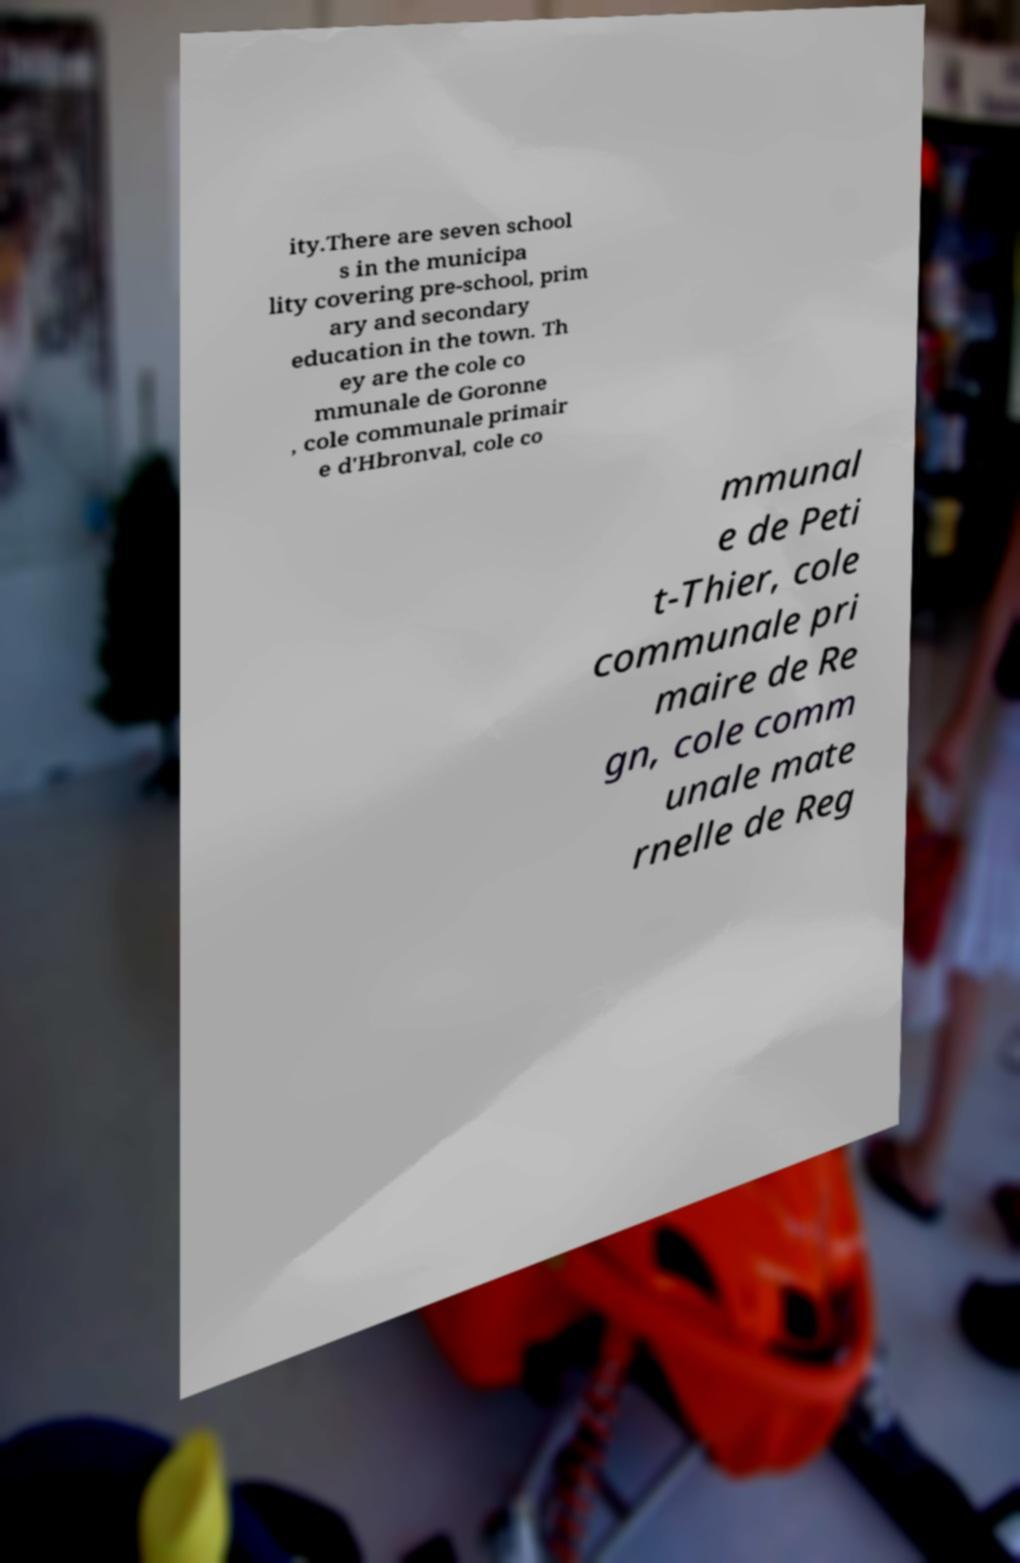Could you assist in decoding the text presented in this image and type it out clearly? ity.There are seven school s in the municipa lity covering pre-school, prim ary and secondary education in the town. Th ey are the cole co mmunale de Goronne , cole communale primair e d'Hbronval, cole co mmunal e de Peti t-Thier, cole communale pri maire de Re gn, cole comm unale mate rnelle de Reg 